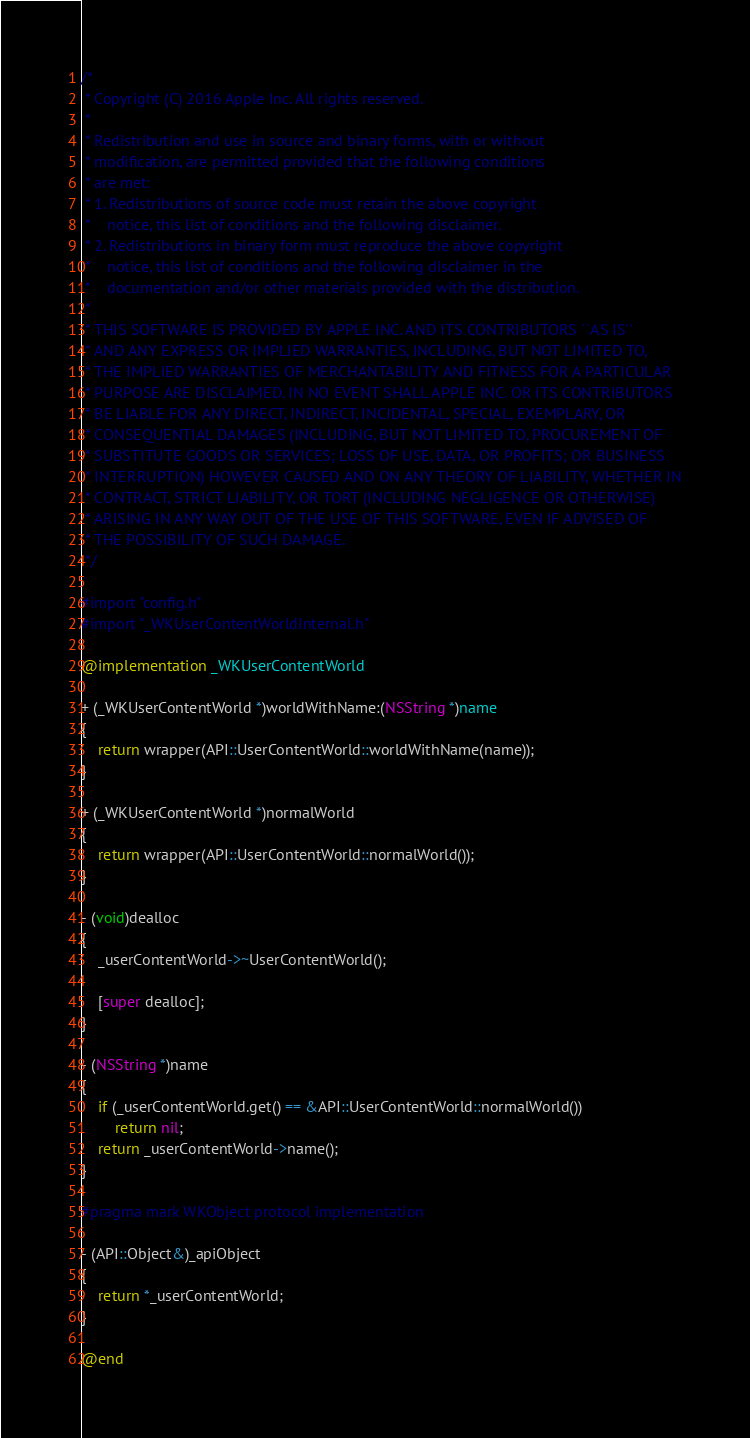Convert code to text. <code><loc_0><loc_0><loc_500><loc_500><_ObjectiveC_>/*
 * Copyright (C) 2016 Apple Inc. All rights reserved.
 *
 * Redistribution and use in source and binary forms, with or without
 * modification, are permitted provided that the following conditions
 * are met:
 * 1. Redistributions of source code must retain the above copyright
 *    notice, this list of conditions and the following disclaimer.
 * 2. Redistributions in binary form must reproduce the above copyright
 *    notice, this list of conditions and the following disclaimer in the
 *    documentation and/or other materials provided with the distribution.
 *
 * THIS SOFTWARE IS PROVIDED BY APPLE INC. AND ITS CONTRIBUTORS ``AS IS''
 * AND ANY EXPRESS OR IMPLIED WARRANTIES, INCLUDING, BUT NOT LIMITED TO,
 * THE IMPLIED WARRANTIES OF MERCHANTABILITY AND FITNESS FOR A PARTICULAR
 * PURPOSE ARE DISCLAIMED. IN NO EVENT SHALL APPLE INC. OR ITS CONTRIBUTORS
 * BE LIABLE FOR ANY DIRECT, INDIRECT, INCIDENTAL, SPECIAL, EXEMPLARY, OR
 * CONSEQUENTIAL DAMAGES (INCLUDING, BUT NOT LIMITED TO, PROCUREMENT OF
 * SUBSTITUTE GOODS OR SERVICES; LOSS OF USE, DATA, OR PROFITS; OR BUSINESS
 * INTERRUPTION) HOWEVER CAUSED AND ON ANY THEORY OF LIABILITY, WHETHER IN
 * CONTRACT, STRICT LIABILITY, OR TORT (INCLUDING NEGLIGENCE OR OTHERWISE)
 * ARISING IN ANY WAY OUT OF THE USE OF THIS SOFTWARE, EVEN IF ADVISED OF
 * THE POSSIBILITY OF SUCH DAMAGE.
 */

#import "config.h"
#import "_WKUserContentWorldInternal.h"

@implementation _WKUserContentWorld

+ (_WKUserContentWorld *)worldWithName:(NSString *)name
{
    return wrapper(API::UserContentWorld::worldWithName(name));
}

+ (_WKUserContentWorld *)normalWorld
{
    return wrapper(API::UserContentWorld::normalWorld());
}

- (void)dealloc
{
    _userContentWorld->~UserContentWorld();

    [super dealloc];
}

- (NSString *)name
{
    if (_userContentWorld.get() == &API::UserContentWorld::normalWorld())
        return nil;
    return _userContentWorld->name();
}

#pragma mark WKObject protocol implementation

- (API::Object&)_apiObject
{
    return *_userContentWorld;
}

@end
</code> 